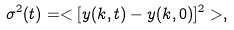Convert formula to latex. <formula><loc_0><loc_0><loc_500><loc_500>\sigma ^ { 2 } ( t ) = < [ y ( k , t ) - y ( k , 0 ) ] ^ { 2 } > ,</formula> 